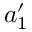<formula> <loc_0><loc_0><loc_500><loc_500>a _ { 1 } ^ { \prime }</formula> 